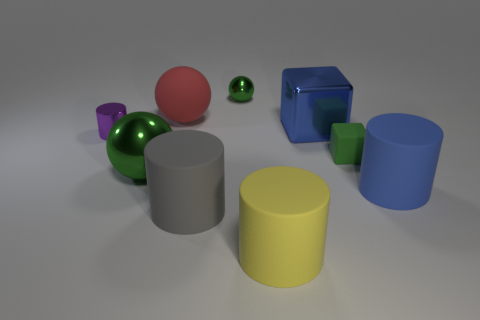Add 1 large yellow cylinders. How many objects exist? 10 Subtract all cylinders. How many objects are left? 5 Subtract all large green metal objects. Subtract all big red matte objects. How many objects are left? 7 Add 1 big blue blocks. How many big blue blocks are left? 2 Add 7 green objects. How many green objects exist? 10 Subtract 0 gray balls. How many objects are left? 9 